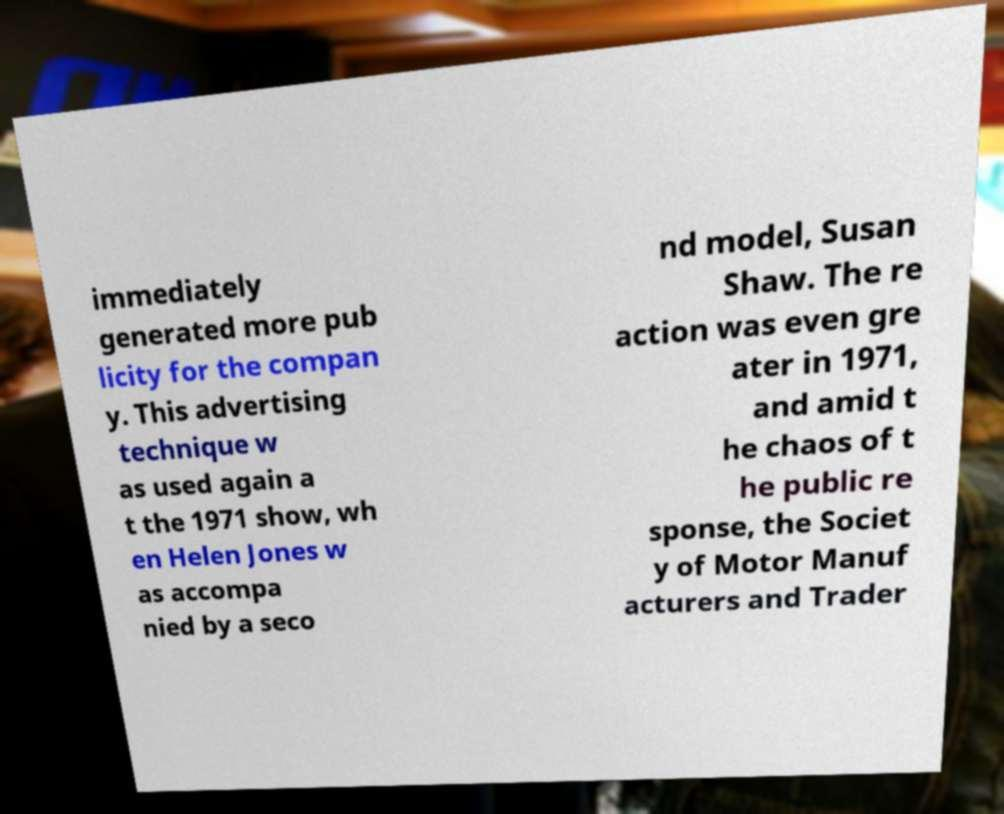For documentation purposes, I need the text within this image transcribed. Could you provide that? immediately generated more pub licity for the compan y. This advertising technique w as used again a t the 1971 show, wh en Helen Jones w as accompa nied by a seco nd model, Susan Shaw. The re action was even gre ater in 1971, and amid t he chaos of t he public re sponse, the Societ y of Motor Manuf acturers and Trader 